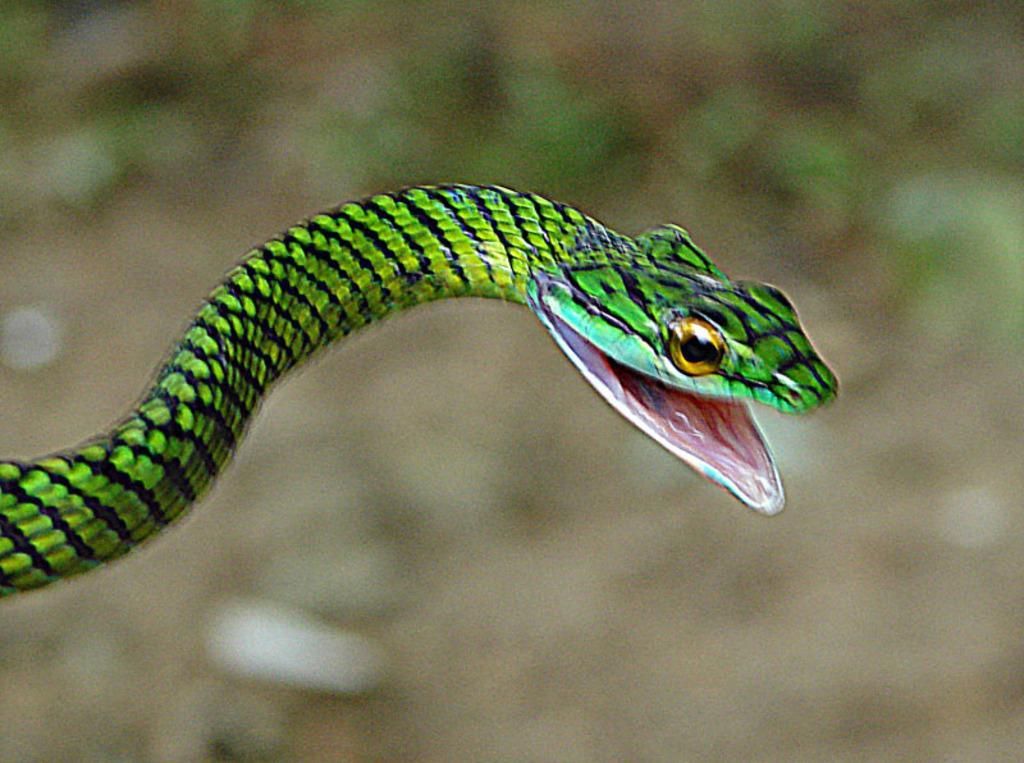In one or two sentences, can you explain what this image depicts? In the image we can see a snake, black and green in color and the background is blurred. 